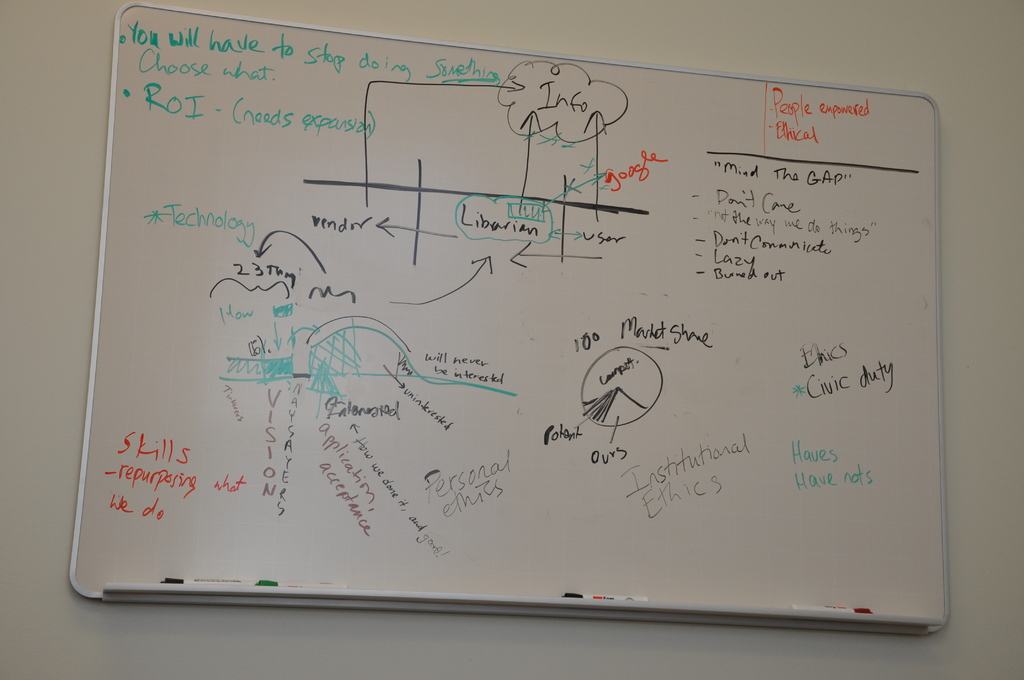What do you see happening in this image? The image depicts a whiteboard filled with various annotations and sketches that suggest it's being used during a corporate strategy meeting or a discussion on efficiency improvements. Key themes revolve around operational ethics, technological enhancements, and resource prioritization, indicated by phrases like 'Choose what to stop doing' and discussions of ROI (Return on Investment). It also touches on interpersonal and industry collaborations, depicted by the drawing of a librarian and user connected by a bridge, hinting at bridging communication gaps. The involvement of different stakeholders, strategic decision-making processes, and alignment of personal with institutional ethics are prominent, showcasing a depth of discussion necessary for mastering complex business or academic challenges. 